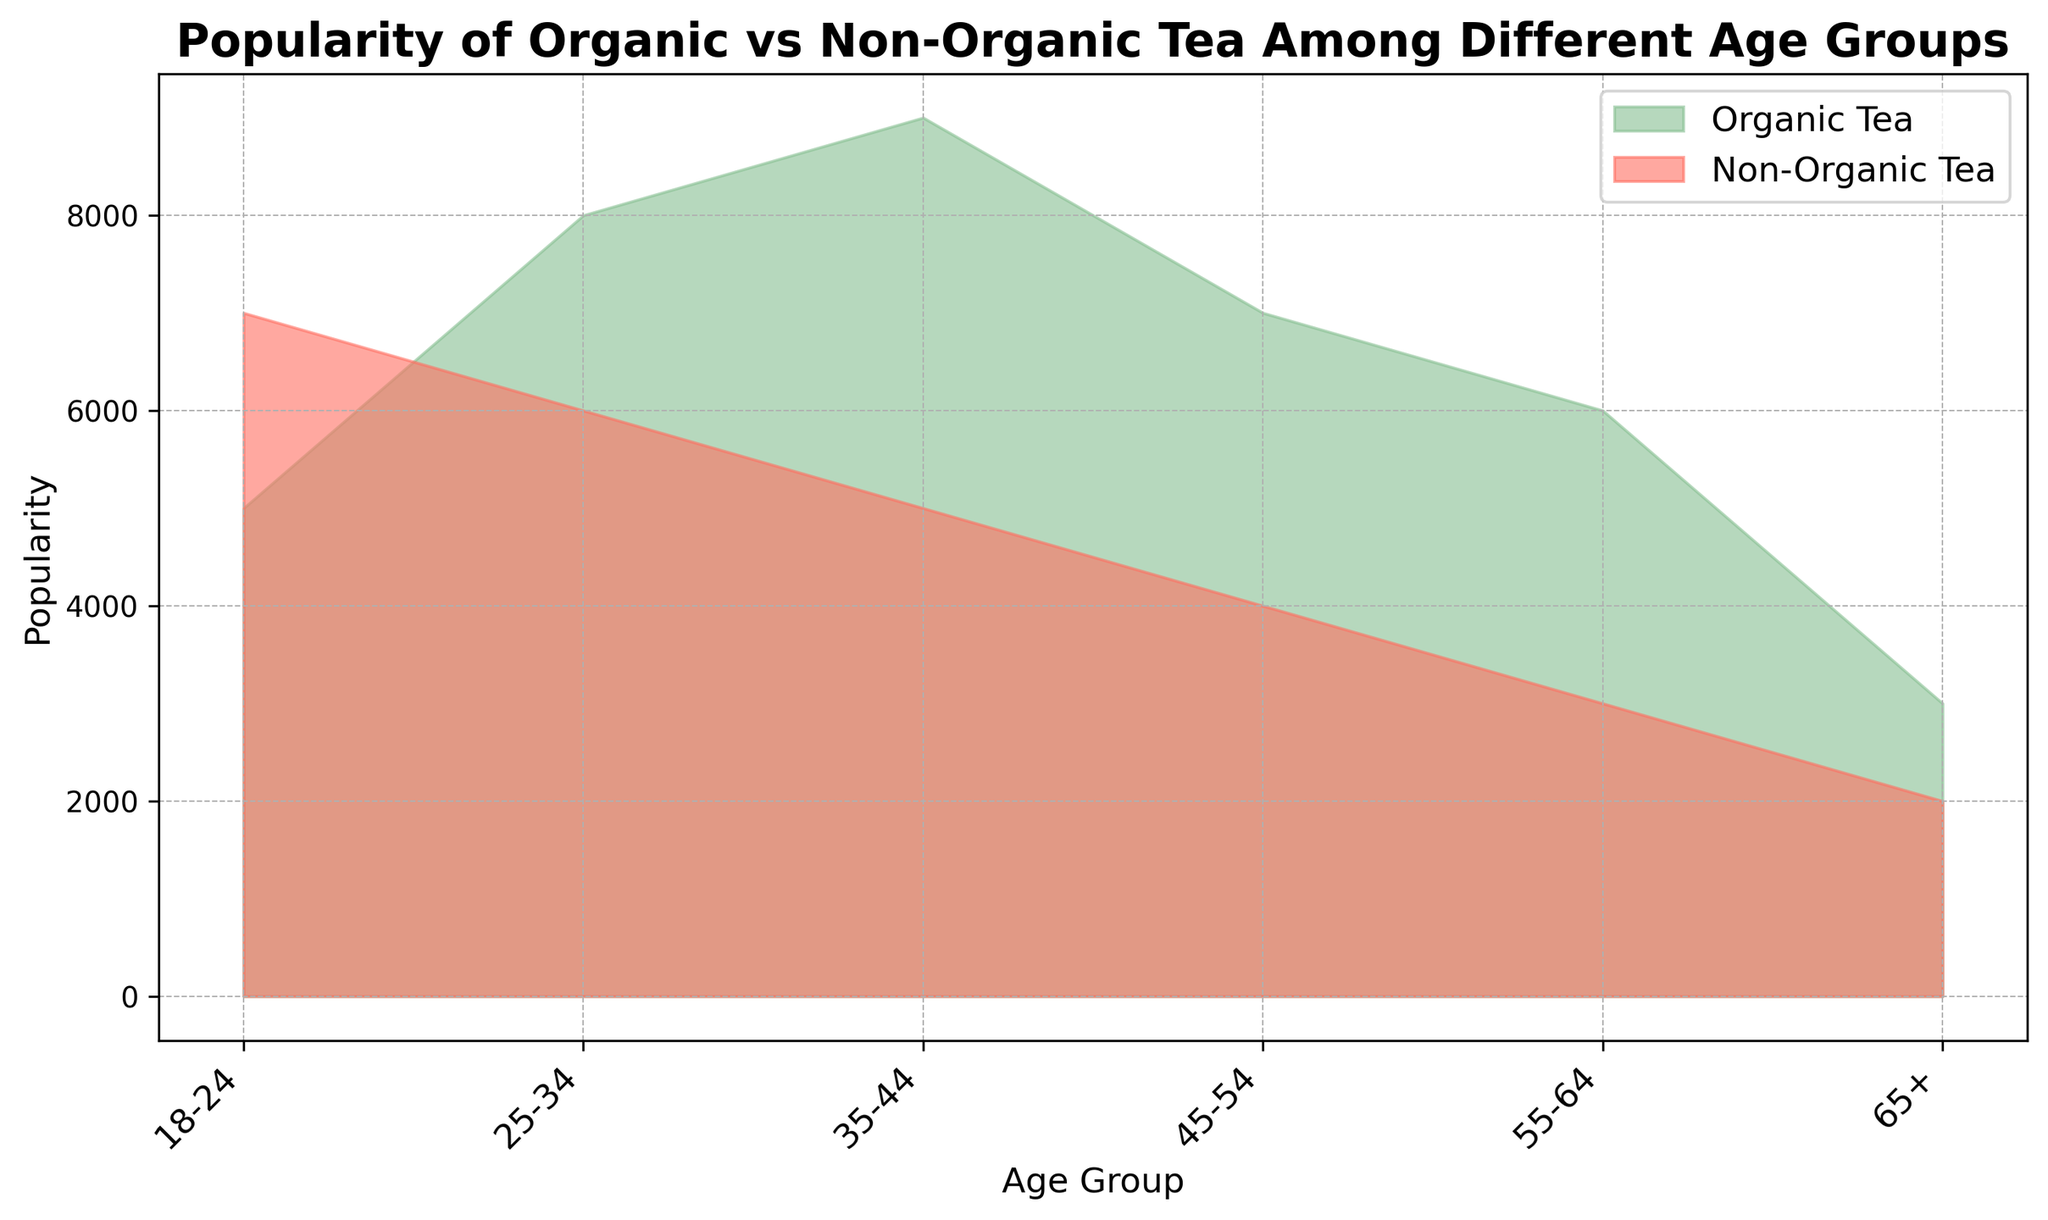Which age group has the highest popularity for organic tea? The plot shows the popularity of organic tea across different age groups. The highest point of the green area, representing organic tea, is at the 35-44 age group.
Answer: 35-44 Which age group has the lowest popularity for both organic and non-organic teas combined? To find the age group with the lowest combined popularity, add the popularity values of organic and non-organic tea for each age group and compare. The 65+ group has the lowest combined total (3000 for organic and 2000 for non-organic, totaling 5000).
Answer: 65+ In which age group is the difference between the popularity of organic tea and non-organic tea the largest? Calculate the difference between organic and non-organic tea popularity for each age group. The largest difference is observed in the 35-44 group: 9000 (organic) - 5000 (non-organic) = 4000.
Answer: 35-44 How does the popularity of non-organic tea in the 18-24 age group compare to that in the 65+ age group? Compare the height of the red area representing non-organic tea in the 18-24 and 65+ age groups. The 18-24 age group has a higher value (7000) compared to the 65+ age group (2000).
Answer: 18-24 is higher What is the sum of the popularity of organic and non-organic teas for the 25-34 age group? Sum the popularity values of both teas for the 25-34 age group. Organic: 8000, Non-Organic: 6000. The sum is 8000 + 6000 = 14000.
Answer: 14000 Which tea type is more popular among the 45-54 age group? Compare the heights of the green (organic) and red (non-organic) areas for the 45-54 age group. The green area is higher, indicating organic tea is more popular.
Answer: Organic tea What is the average popularity of organic tea for the age groups over 35? For age groups 35-44, 45-54, 55-64, and 65+: Calculate the mean of the values 9000, 7000, 6000, and 3000. (9000 + 7000 + 6000 + 3000) / 4 = 6250.
Answer: 6250 What is the trend in the popularity of organic tea as age increases from 18-24 to 65+? Observe how the green area changes as you move from left to right in the chart. The popularity of organic tea initially increases, peaks at 35-44, and then generally decreases as age increases.
Answer: Increases then decreases Is there any age group where the popularity of non-organic tea is higher than that of organic tea? Compare the heights of the green (organic) and red (non-organic) areas for all age groups. Non-organic tea is higher in the 18-24 age group only.
Answer: 18-24 